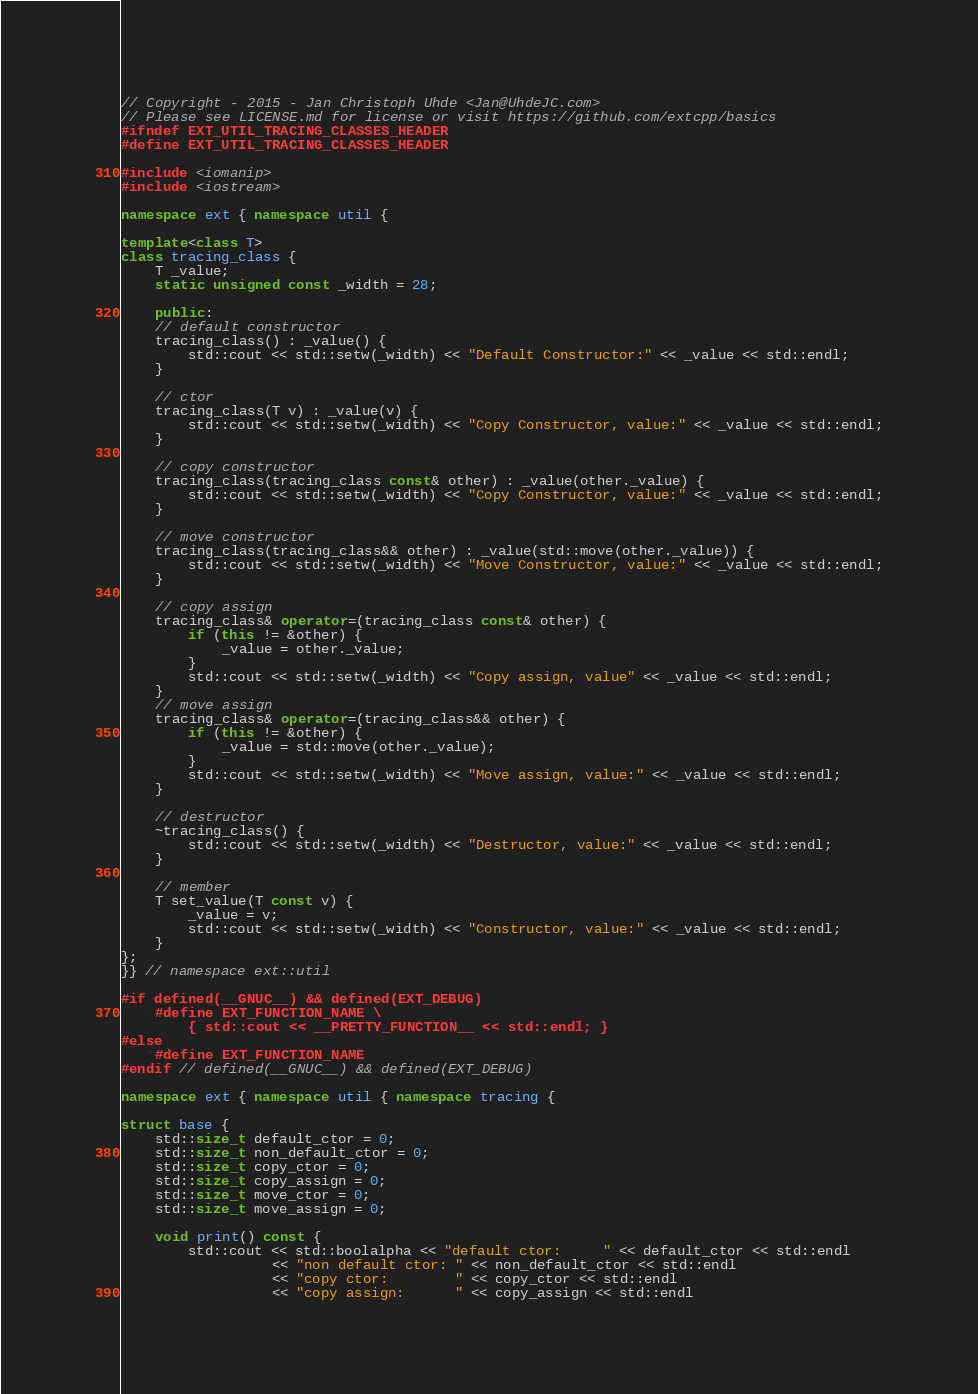Convert code to text. <code><loc_0><loc_0><loc_500><loc_500><_C++_>// Copyright - 2015 - Jan Christoph Uhde <Jan@UhdeJC.com>
// Please see LICENSE.md for license or visit https://github.com/extcpp/basics
#ifndef EXT_UTIL_TRACING_CLASSES_HEADER
#define EXT_UTIL_TRACING_CLASSES_HEADER

#include <iomanip>
#include <iostream>

namespace ext { namespace util {

template<class T>
class tracing_class {
    T _value;
    static unsigned const _width = 28;

    public:
    // default constructor
    tracing_class() : _value() {
        std::cout << std::setw(_width) << "Default Constructor:" << _value << std::endl;
    }

    // ctor
    tracing_class(T v) : _value(v) {
        std::cout << std::setw(_width) << "Copy Constructor, value:" << _value << std::endl;
    }

    // copy constructor
    tracing_class(tracing_class const& other) : _value(other._value) {
        std::cout << std::setw(_width) << "Copy Constructor, value:" << _value << std::endl;
    }

    // move constructor
    tracing_class(tracing_class&& other) : _value(std::move(other._value)) {
        std::cout << std::setw(_width) << "Move Constructor, value:" << _value << std::endl;
    }

    // copy assign
    tracing_class& operator=(tracing_class const& other) {
        if (this != &other) {
            _value = other._value;
        }
        std::cout << std::setw(_width) << "Copy assign, value" << _value << std::endl;
    }
    // move assign
    tracing_class& operator=(tracing_class&& other) {
        if (this != &other) {
            _value = std::move(other._value);
        }
        std::cout << std::setw(_width) << "Move assign, value:" << _value << std::endl;
    }

    // destructor
    ~tracing_class() {
        std::cout << std::setw(_width) << "Destructor, value:" << _value << std::endl;
    }

    // member
    T set_value(T const v) {
        _value = v;
        std::cout << std::setw(_width) << "Constructor, value:" << _value << std::endl;
    }
};
}} // namespace ext::util

#if defined(__GNUC__) && defined(EXT_DEBUG)
    #define EXT_FUNCTION_NAME \
        { std::cout << __PRETTY_FUNCTION__ << std::endl; }
#else
    #define EXT_FUNCTION_NAME
#endif // defined(__GNUC__) && defined(EXT_DEBUG)

namespace ext { namespace util { namespace tracing {

struct base {
    std::size_t default_ctor = 0;
    std::size_t non_default_ctor = 0;
    std::size_t copy_ctor = 0;
    std::size_t copy_assign = 0;
    std::size_t move_ctor = 0;
    std::size_t move_assign = 0;

    void print() const {
        std::cout << std::boolalpha << "default ctor:     " << default_ctor << std::endl
                  << "non default ctor: " << non_default_ctor << std::endl
                  << "copy ctor:        " << copy_ctor << std::endl
                  << "copy assign:      " << copy_assign << std::endl</code> 